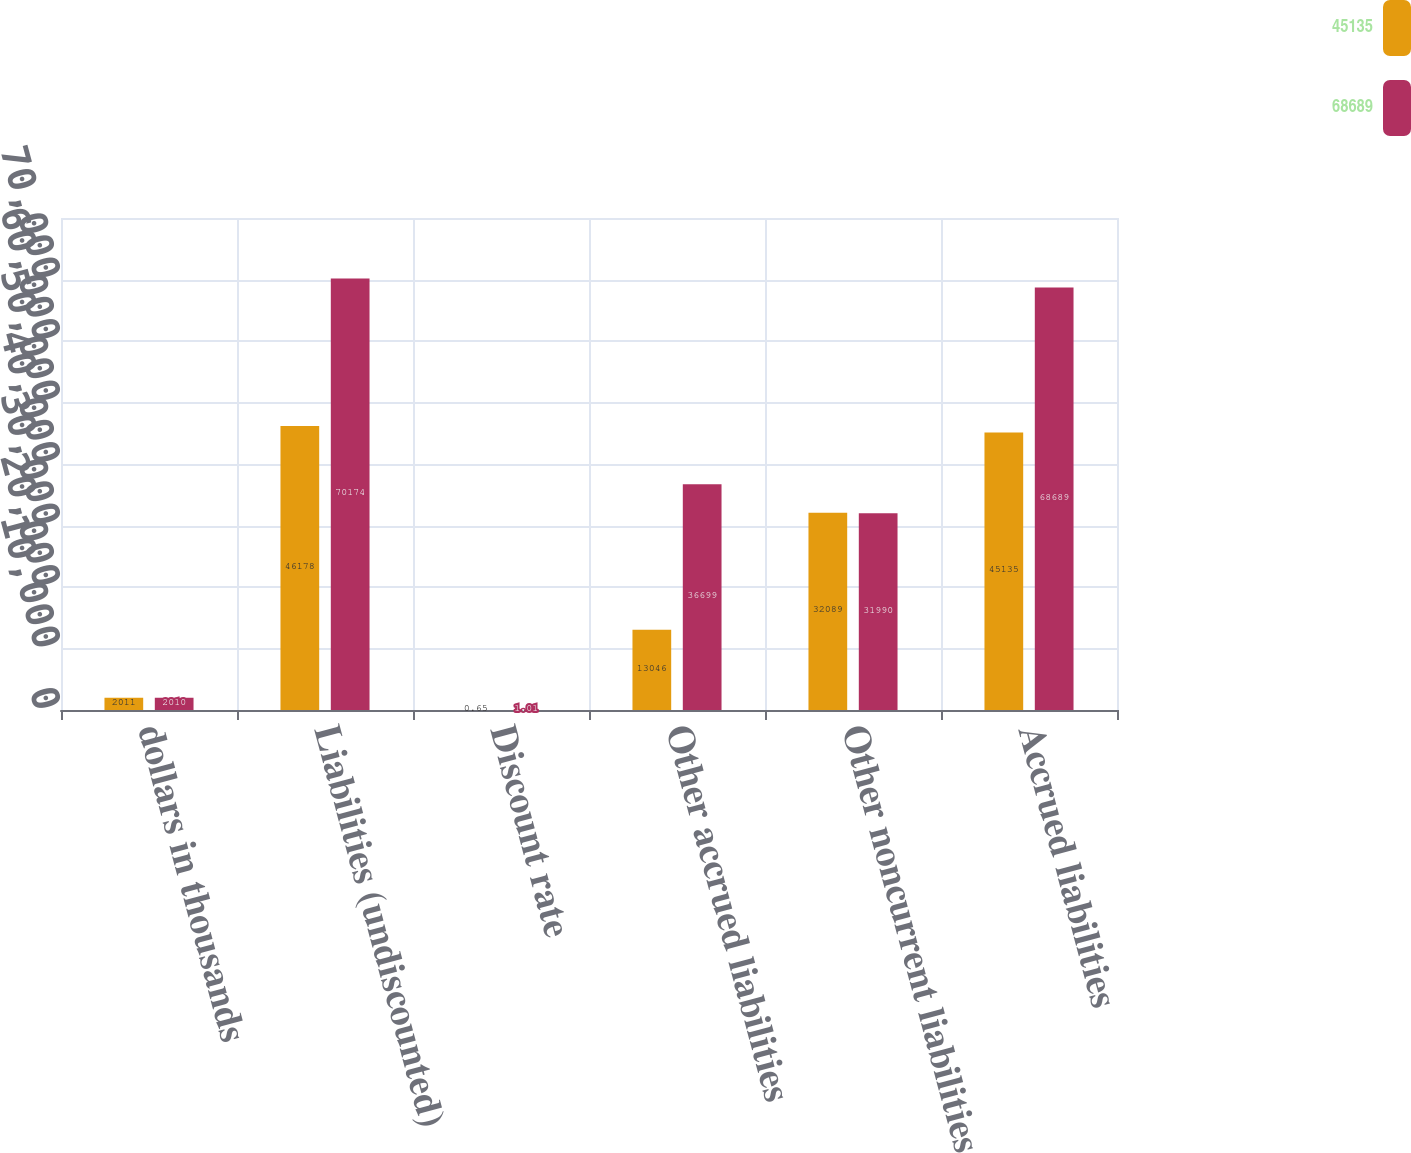Convert chart. <chart><loc_0><loc_0><loc_500><loc_500><stacked_bar_chart><ecel><fcel>dollars in thousands<fcel>Liabilities (undiscounted)<fcel>Discount rate<fcel>Other accrued liabilities<fcel>Other noncurrent liabilities<fcel>Accrued liabilities<nl><fcel>45135<fcel>2011<fcel>46178<fcel>0.65<fcel>13046<fcel>32089<fcel>45135<nl><fcel>68689<fcel>2010<fcel>70174<fcel>1.01<fcel>36699<fcel>31990<fcel>68689<nl></chart> 